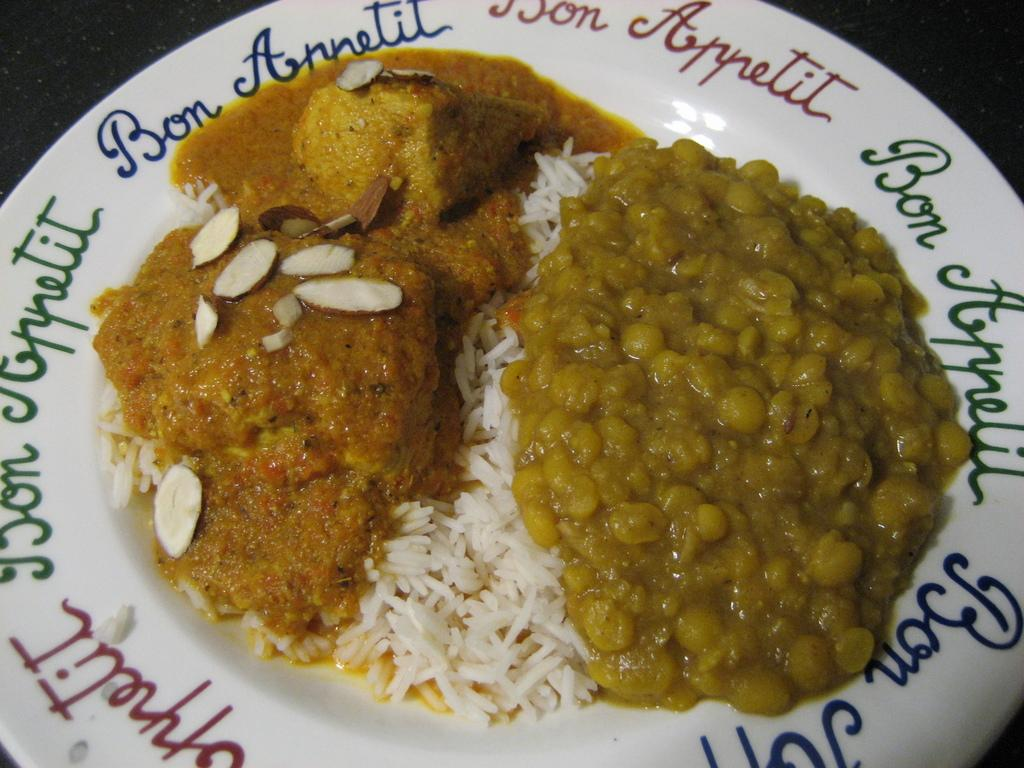What is on the plate that is visible in the image? There is rice, curry, dry fruits, and other items on the plate. What is written on the plate? There are letters on the plate. What type of food is on the plate? The plate contains rice, curry, and dry fruits. What else can be seen on the plate? There are other items on the plate. What is the color of the background in the image? The background of the image appears dark. Can you see any ants crawling on the plate in the image? There are no ants visible on the plate in the image. 